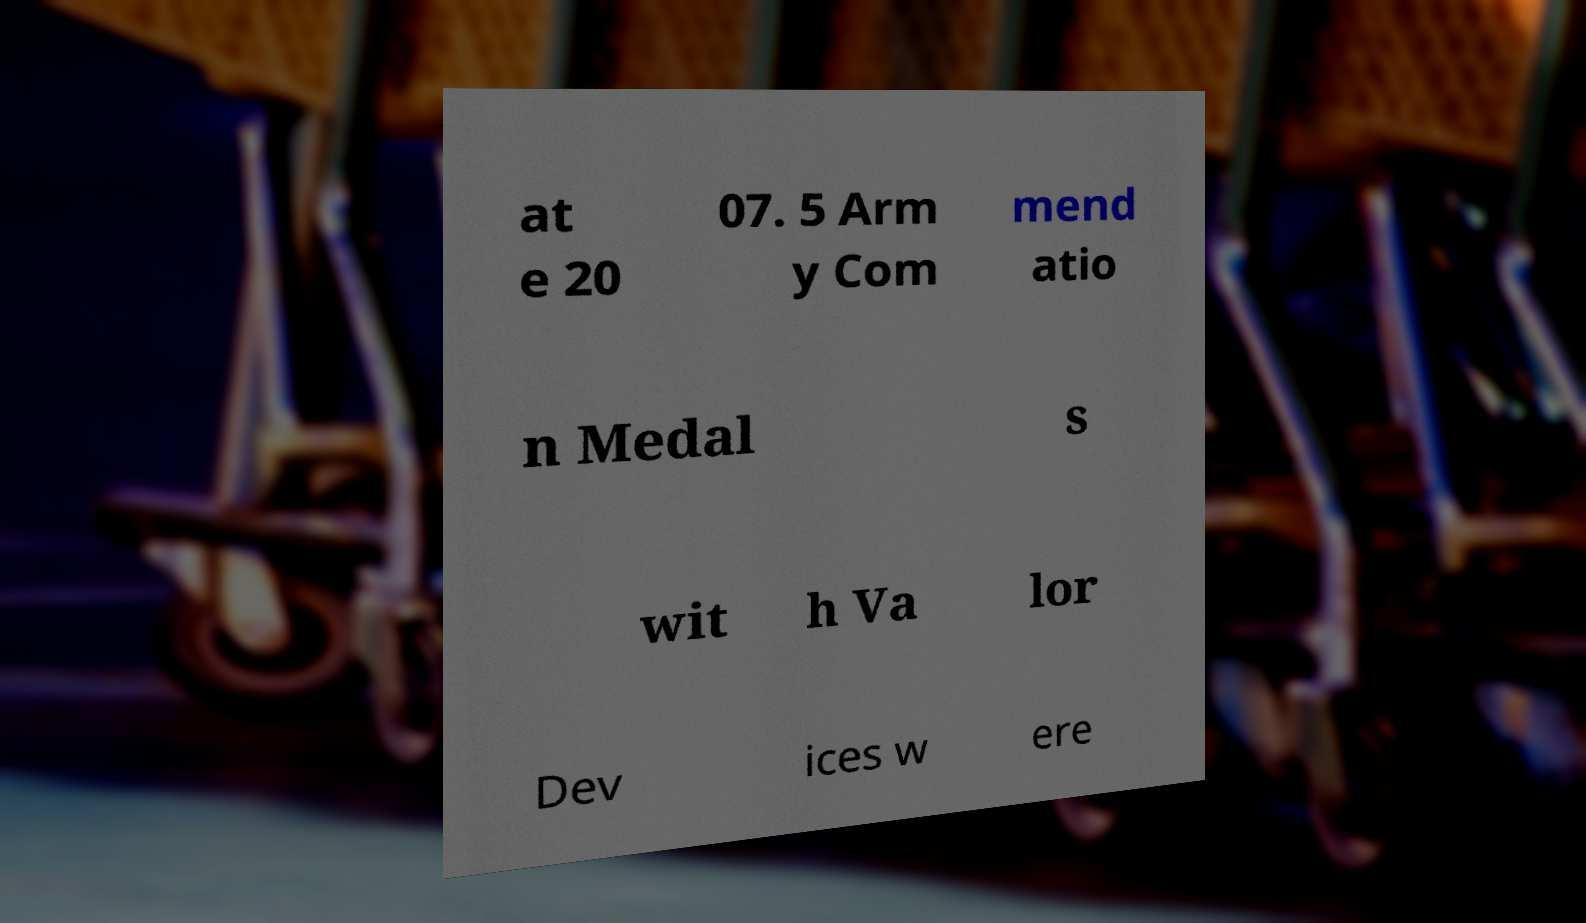Please identify and transcribe the text found in this image. at e 20 07. 5 Arm y Com mend atio n Medal s wit h Va lor Dev ices w ere 